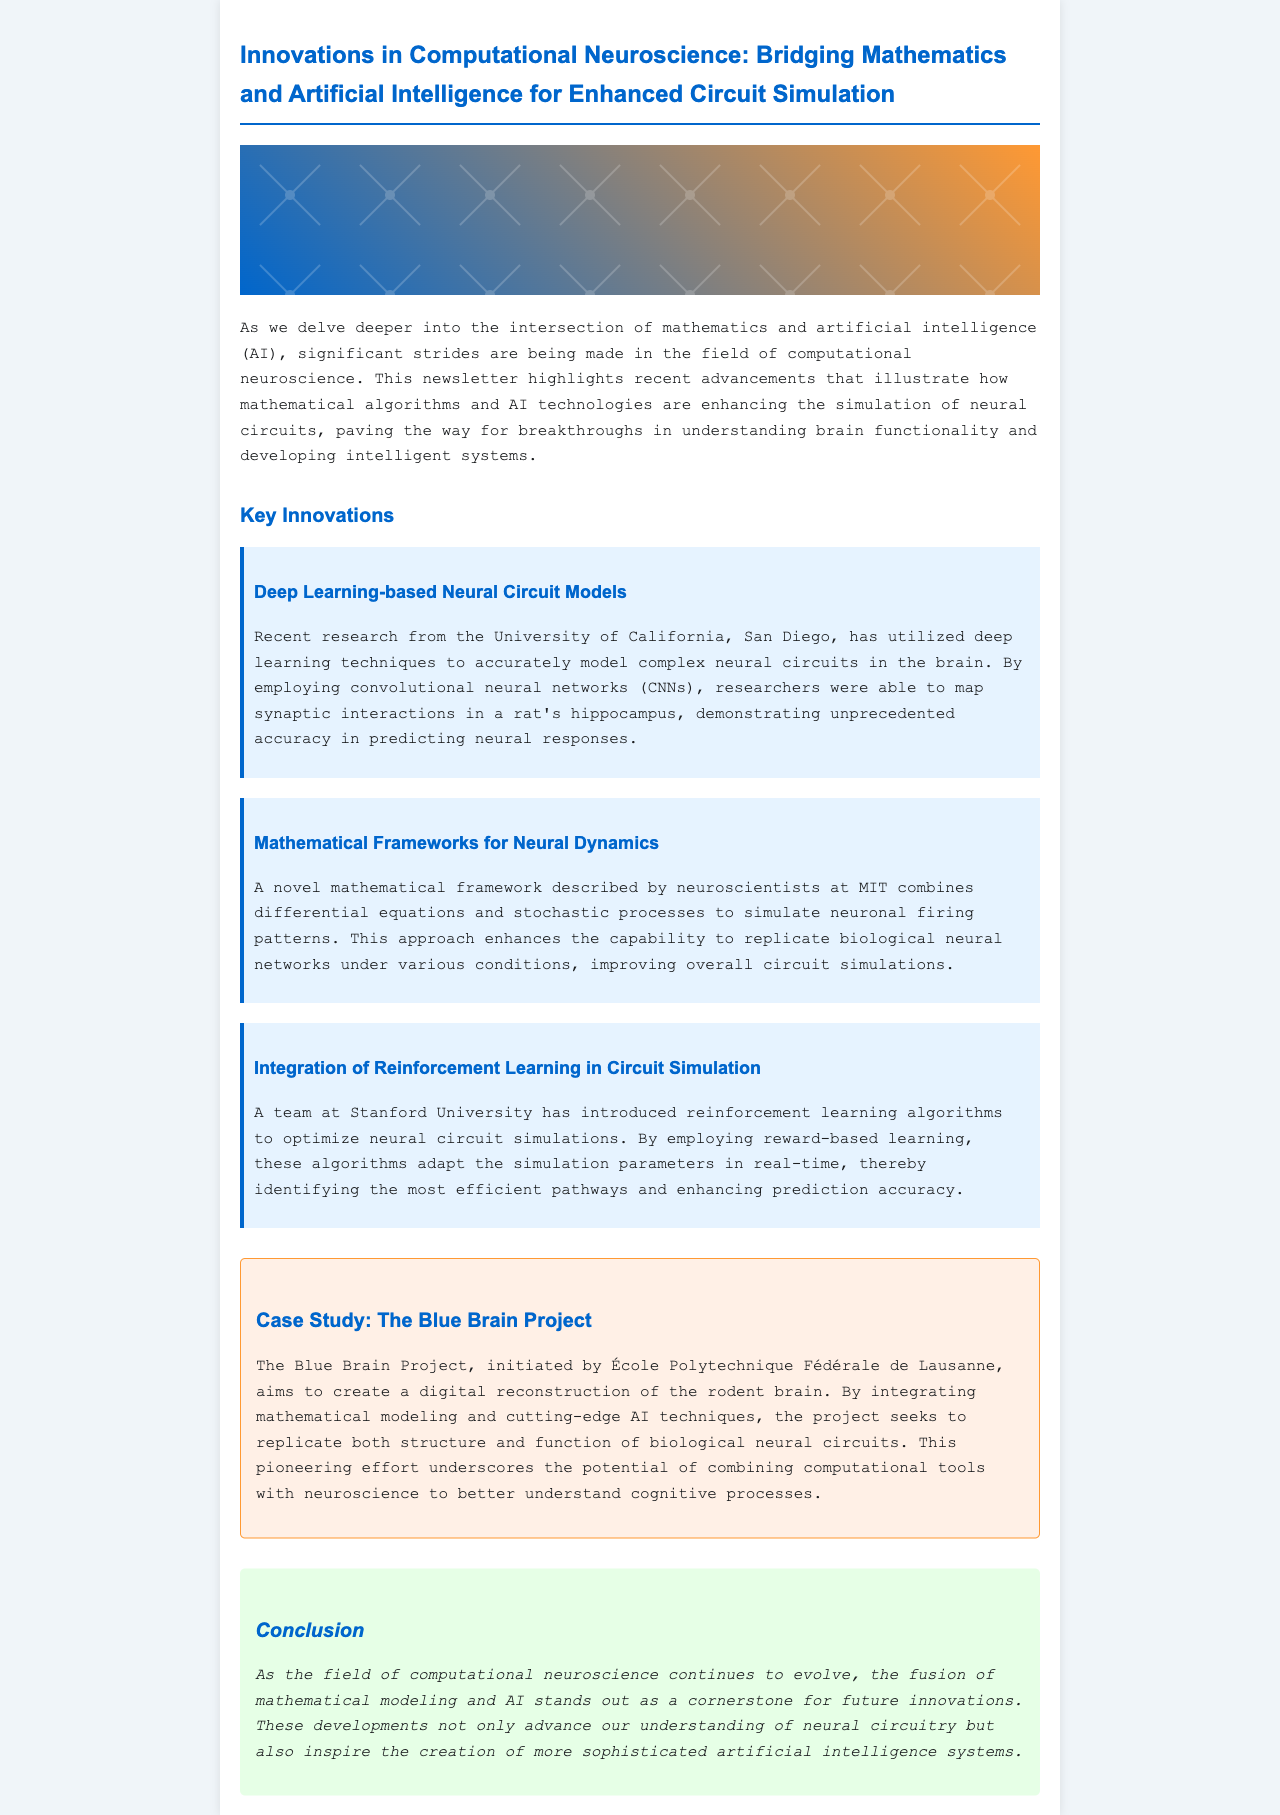what is the title of the newsletter? The title can be found at the top of the document, stating the main focus of the content.
Answer: Innovations in Computational Neuroscience: Bridging Mathematics and Artificial Intelligence for Enhanced Circuit Simulation which university conducted research on deep learning-based neural circuit models? The university responsible for this research is mentioned in the section discussing key innovations.
Answer: University of California, San Diego what type of networks were used to model synaptic interactions? The specific method employed in the research is indicated in the description of the innovation related to deep learning.
Answer: Convolutional neural networks who initiated the Blue Brain Project? The document provides a reference to the organization that started this significant project within neuroscience.
Answer: École Polytechnique Fédérale de Lausanne what approach enhances the capability to replicate biological neural networks? This enhancement method is detailed in the innovation describing mathematical frameworks for neural dynamics.
Answer: Combining differential equations and stochastic processes how do reinforcement learning algorithms contribute to circuit simulation? The role of these algorithms in circuit simulation is explained in the corresponding innovation section.
Answer: Optimize neural circuit simulations what is the focus of the Blue Brain Project? The primary objective of this project is outlined in the case study section.
Answer: Create a digital reconstruction of the rodent brain which mathematical concept is combined with AI techniques in the document's innovations? The innovations discussed emphasize the integration of mathematical concepts combined with AI to improve circuit simulation.
Answer: Mathematical modeling 